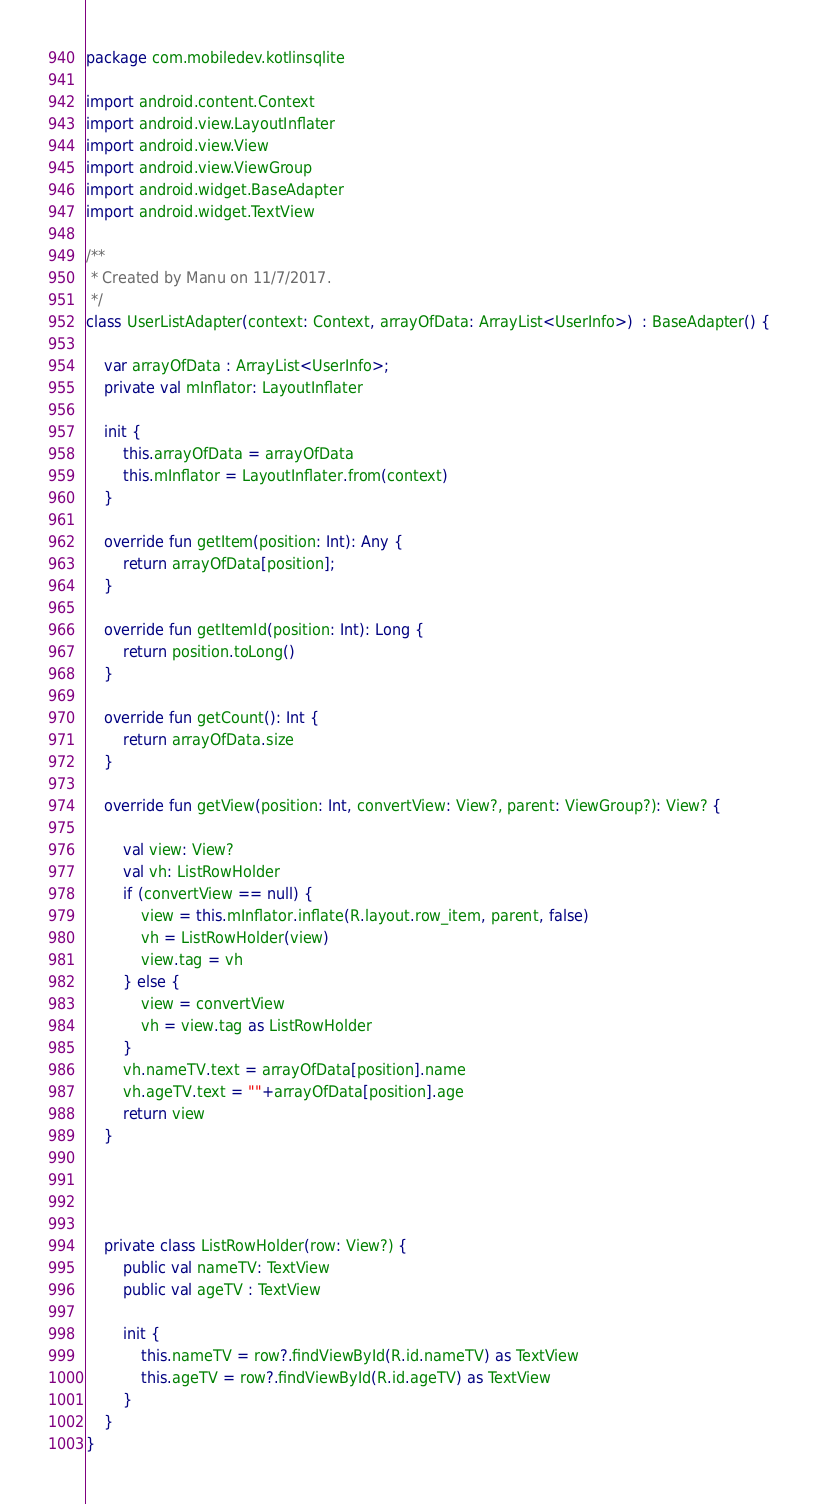<code> <loc_0><loc_0><loc_500><loc_500><_Kotlin_>package com.mobiledev.kotlinsqlite

import android.content.Context
import android.view.LayoutInflater
import android.view.View
import android.view.ViewGroup
import android.widget.BaseAdapter
import android.widget.TextView

/**
 * Created by Manu on 11/7/2017.
 */
class UserListAdapter(context: Context, arrayOfData: ArrayList<UserInfo>)  : BaseAdapter() {

    var arrayOfData : ArrayList<UserInfo>;
    private val mInflator: LayoutInflater

    init {
        this.arrayOfData = arrayOfData
        this.mInflator = LayoutInflater.from(context)
    }

    override fun getItem(position: Int): Any {
        return arrayOfData[position];
    }

    override fun getItemId(position: Int): Long {
        return position.toLong()
    }

    override fun getCount(): Int {
        return arrayOfData.size
    }

    override fun getView(position: Int, convertView: View?, parent: ViewGroup?): View? {

        val view: View?
        val vh: ListRowHolder
        if (convertView == null) {
            view = this.mInflator.inflate(R.layout.row_item, parent, false)
            vh = ListRowHolder(view)
            view.tag = vh
        } else {
            view = convertView
            vh = view.tag as ListRowHolder
        }
        vh.nameTV.text = arrayOfData[position].name
        vh.ageTV.text = ""+arrayOfData[position].age
        return view
    }




    private class ListRowHolder(row: View?) {
        public val nameTV: TextView
        public val ageTV : TextView

        init {
            this.nameTV = row?.findViewById(R.id.nameTV) as TextView
            this.ageTV = row?.findViewById(R.id.ageTV) as TextView
        }
    }
}</code> 